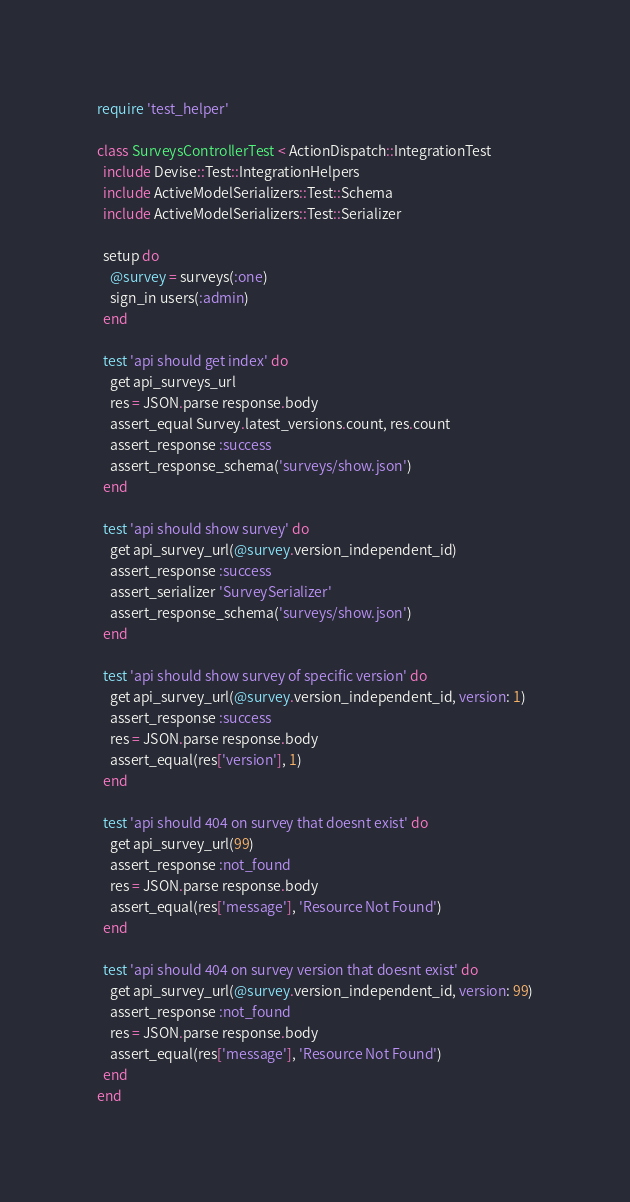<code> <loc_0><loc_0><loc_500><loc_500><_Ruby_>require 'test_helper'

class SurveysControllerTest < ActionDispatch::IntegrationTest
  include Devise::Test::IntegrationHelpers
  include ActiveModelSerializers::Test::Schema
  include ActiveModelSerializers::Test::Serializer

  setup do
    @survey = surveys(:one)
    sign_in users(:admin)
  end

  test 'api should get index' do
    get api_surveys_url
    res = JSON.parse response.body
    assert_equal Survey.latest_versions.count, res.count
    assert_response :success
    assert_response_schema('surveys/show.json')
  end

  test 'api should show survey' do
    get api_survey_url(@survey.version_independent_id)
    assert_response :success
    assert_serializer 'SurveySerializer'
    assert_response_schema('surveys/show.json')
  end

  test 'api should show survey of specific version' do
    get api_survey_url(@survey.version_independent_id, version: 1)
    assert_response :success
    res = JSON.parse response.body
    assert_equal(res['version'], 1)
  end

  test 'api should 404 on survey that doesnt exist' do
    get api_survey_url(99)
    assert_response :not_found
    res = JSON.parse response.body
    assert_equal(res['message'], 'Resource Not Found')
  end

  test 'api should 404 on survey version that doesnt exist' do
    get api_survey_url(@survey.version_independent_id, version: 99)
    assert_response :not_found
    res = JSON.parse response.body
    assert_equal(res['message'], 'Resource Not Found')
  end
end
</code> 